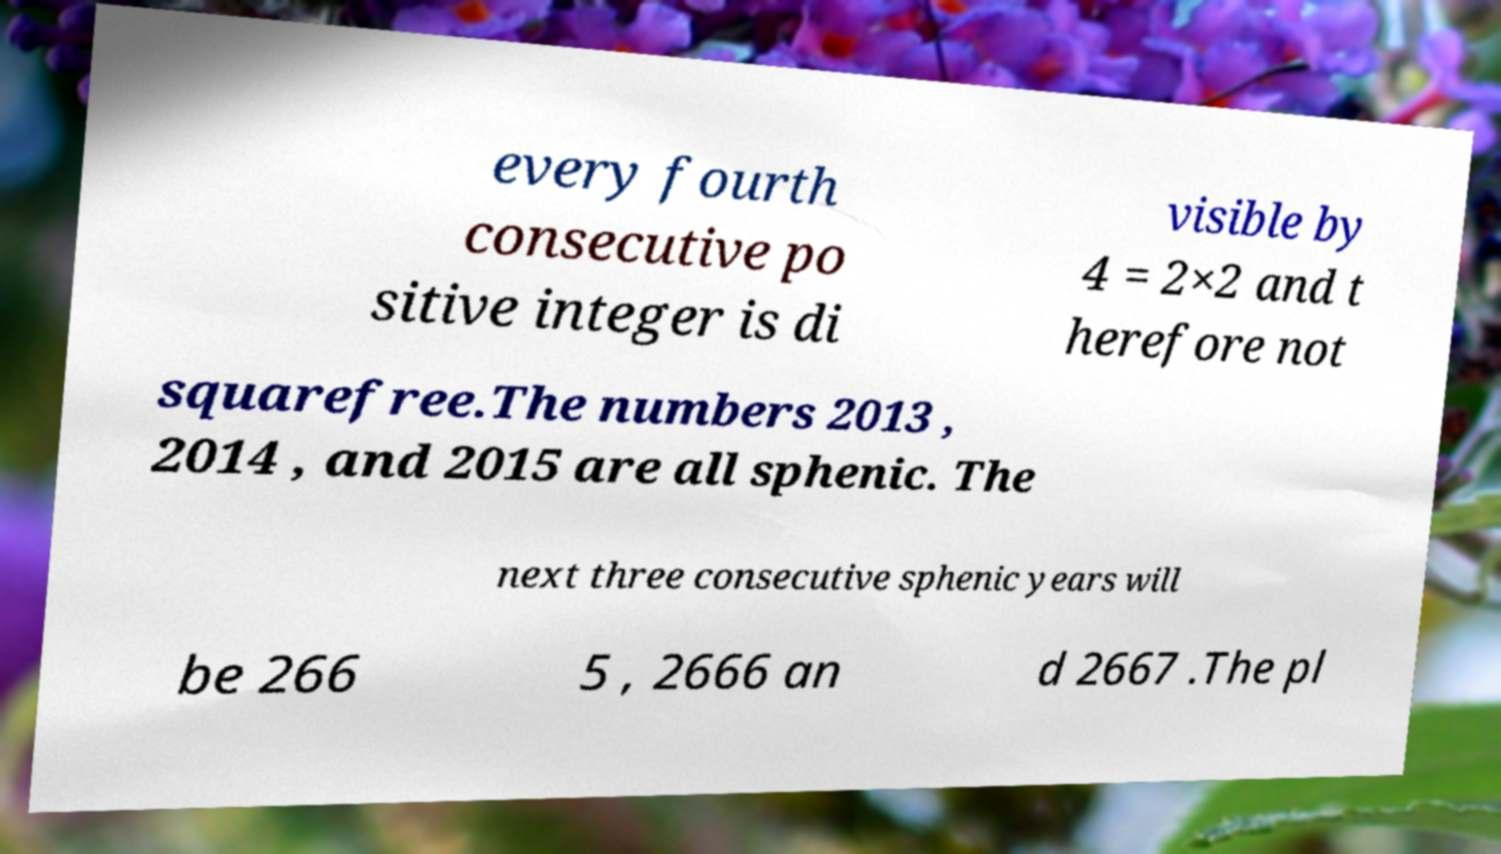Can you accurately transcribe the text from the provided image for me? every fourth consecutive po sitive integer is di visible by 4 = 2×2 and t herefore not squarefree.The numbers 2013 , 2014 , and 2015 are all sphenic. The next three consecutive sphenic years will be 266 5 , 2666 an d 2667 .The pl 